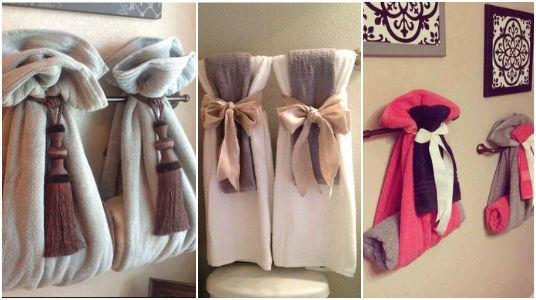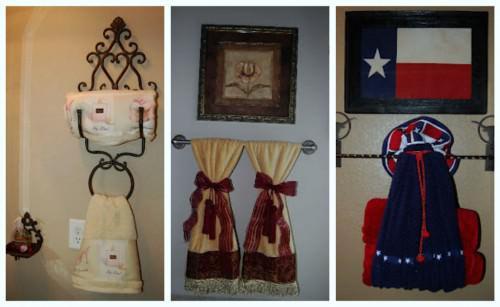The first image is the image on the left, the second image is the image on the right. Considering the images on both sides, is "Each image shows multiple hand towel decor ideas." valid? Answer yes or no. Yes. 